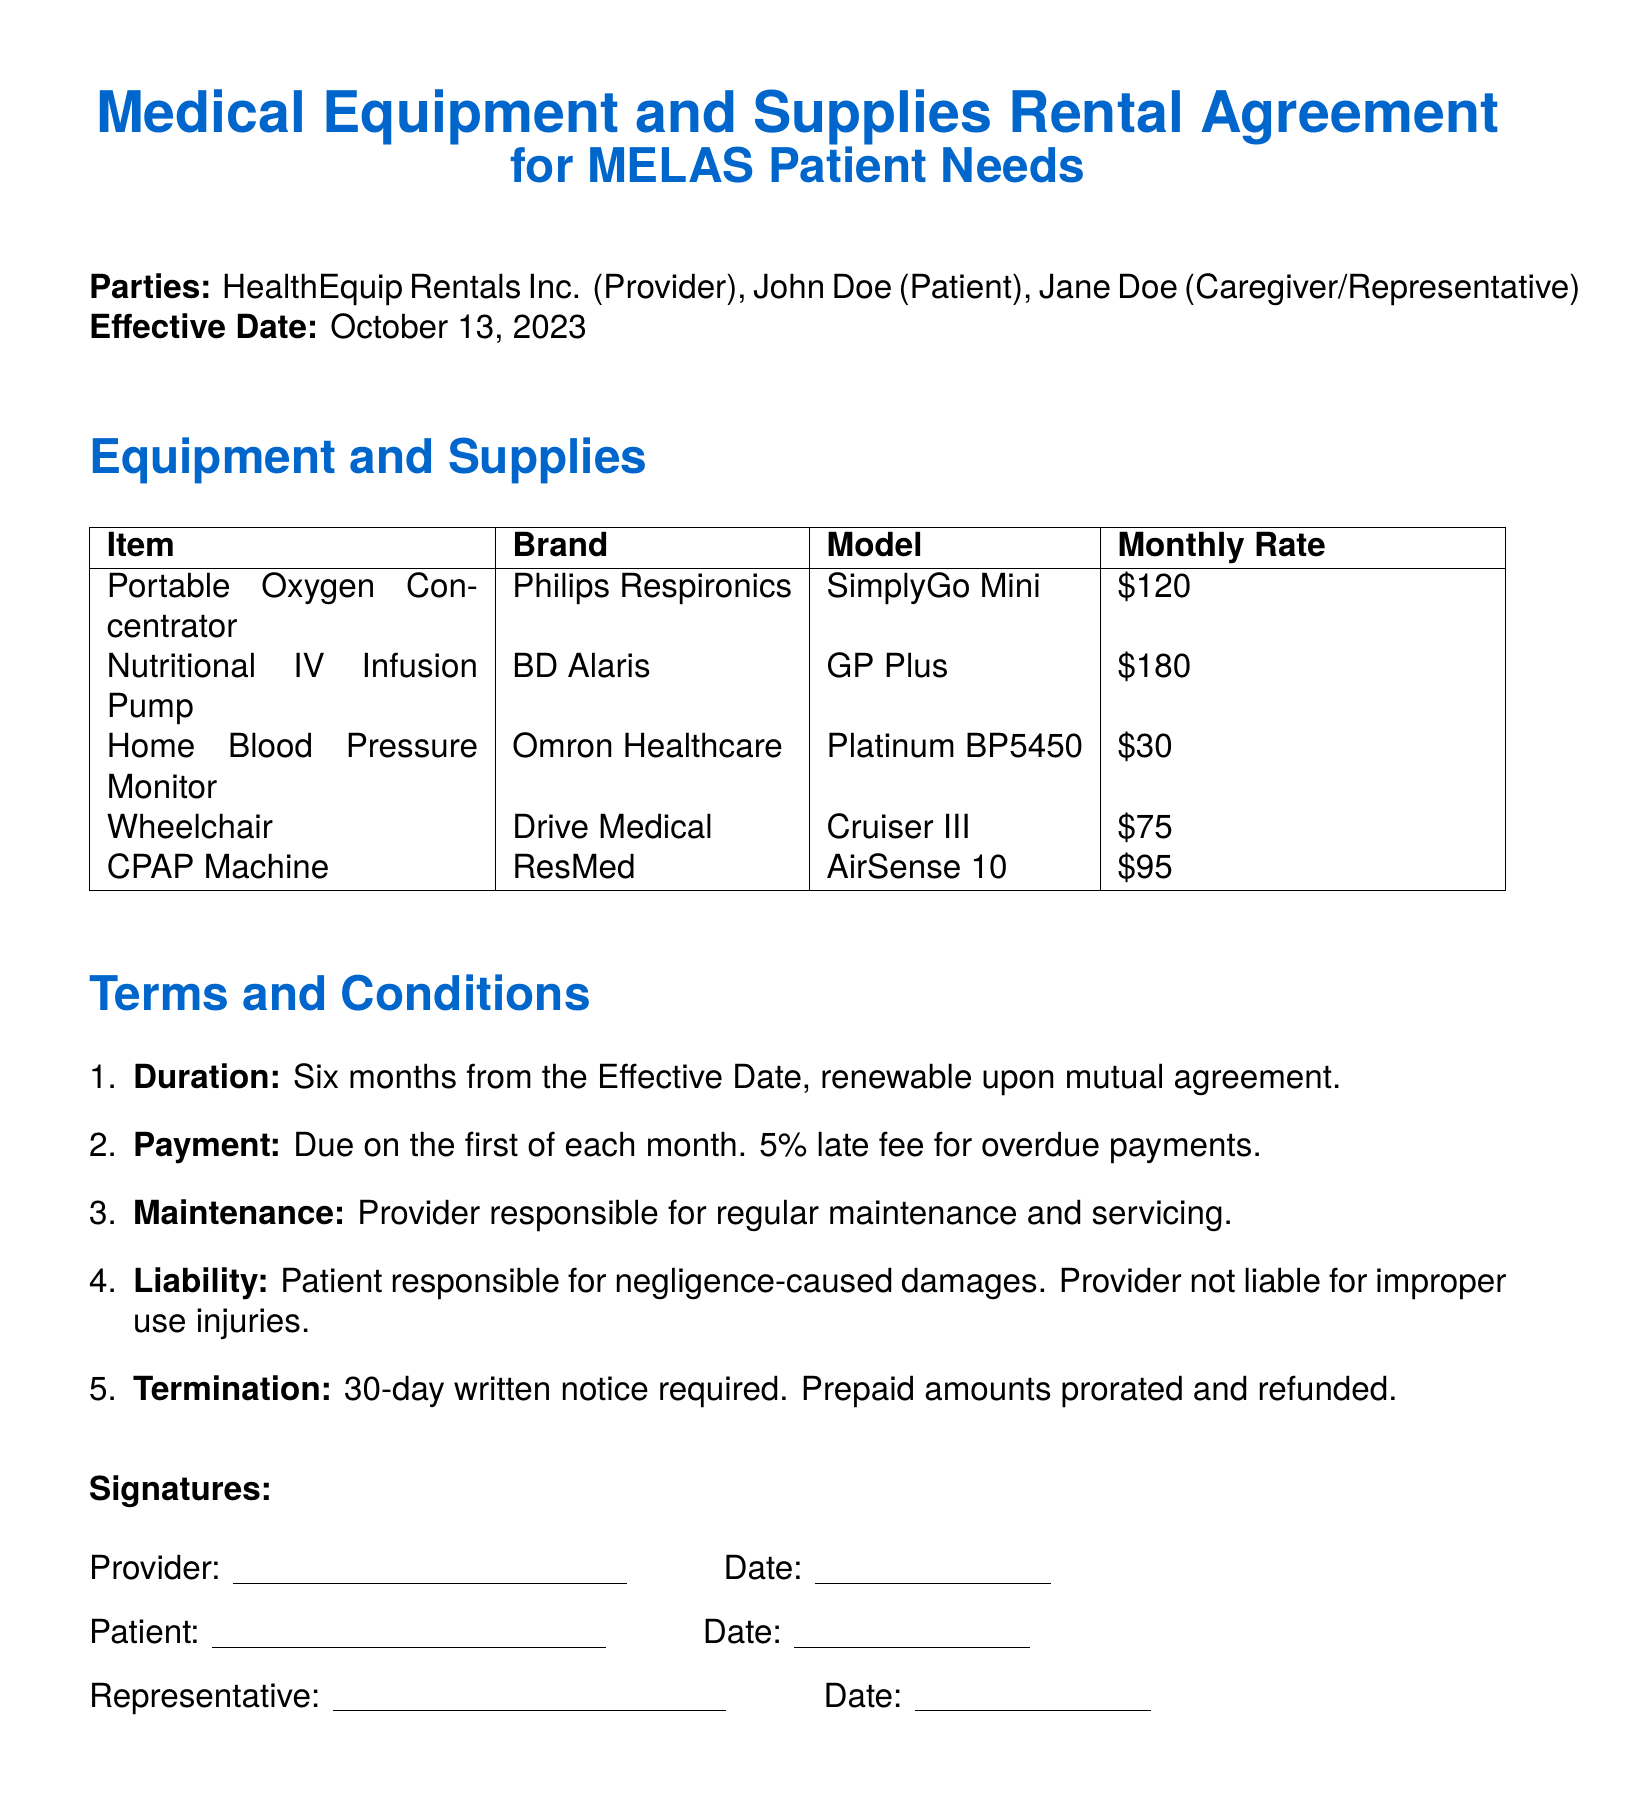What is the name of the provider? The provider's name is listed at the beginning of the agreement.
Answer: HealthEquip Rentals Inc What is the effective date of the agreement? The effective date is specified in the introduction section of the document.
Answer: October 13, 2023 What is the monthly rate for the Nutritional IV Infusion Pump? The monthly rate for this item is mentioned in the equipment table.
Answer: $180 How long is the duration of the rental agreement? The duration is specified clearly in the terms and conditions section.
Answer: Six months What happens if payment is overdue? The document outlines the consequence of late payments under the payment terms.
Answer: 5% late fee Who is responsible for regular maintenance? The terms specifically outline the responsibilities for maintenance.
Answer: Provider What notice is required for termination? The termination clause details what is needed from the patient or provider.
Answer: 30-day written notice Which item has the lowest monthly rental rate? The equipment table shows the rates for each item, allowing comparison.
Answer: Home Blood Pressure Monitor What is the model of the Portable Oxygen Concentrator? The model name is specified next to the item in the equipment section.
Answer: SimplyGo Mini 